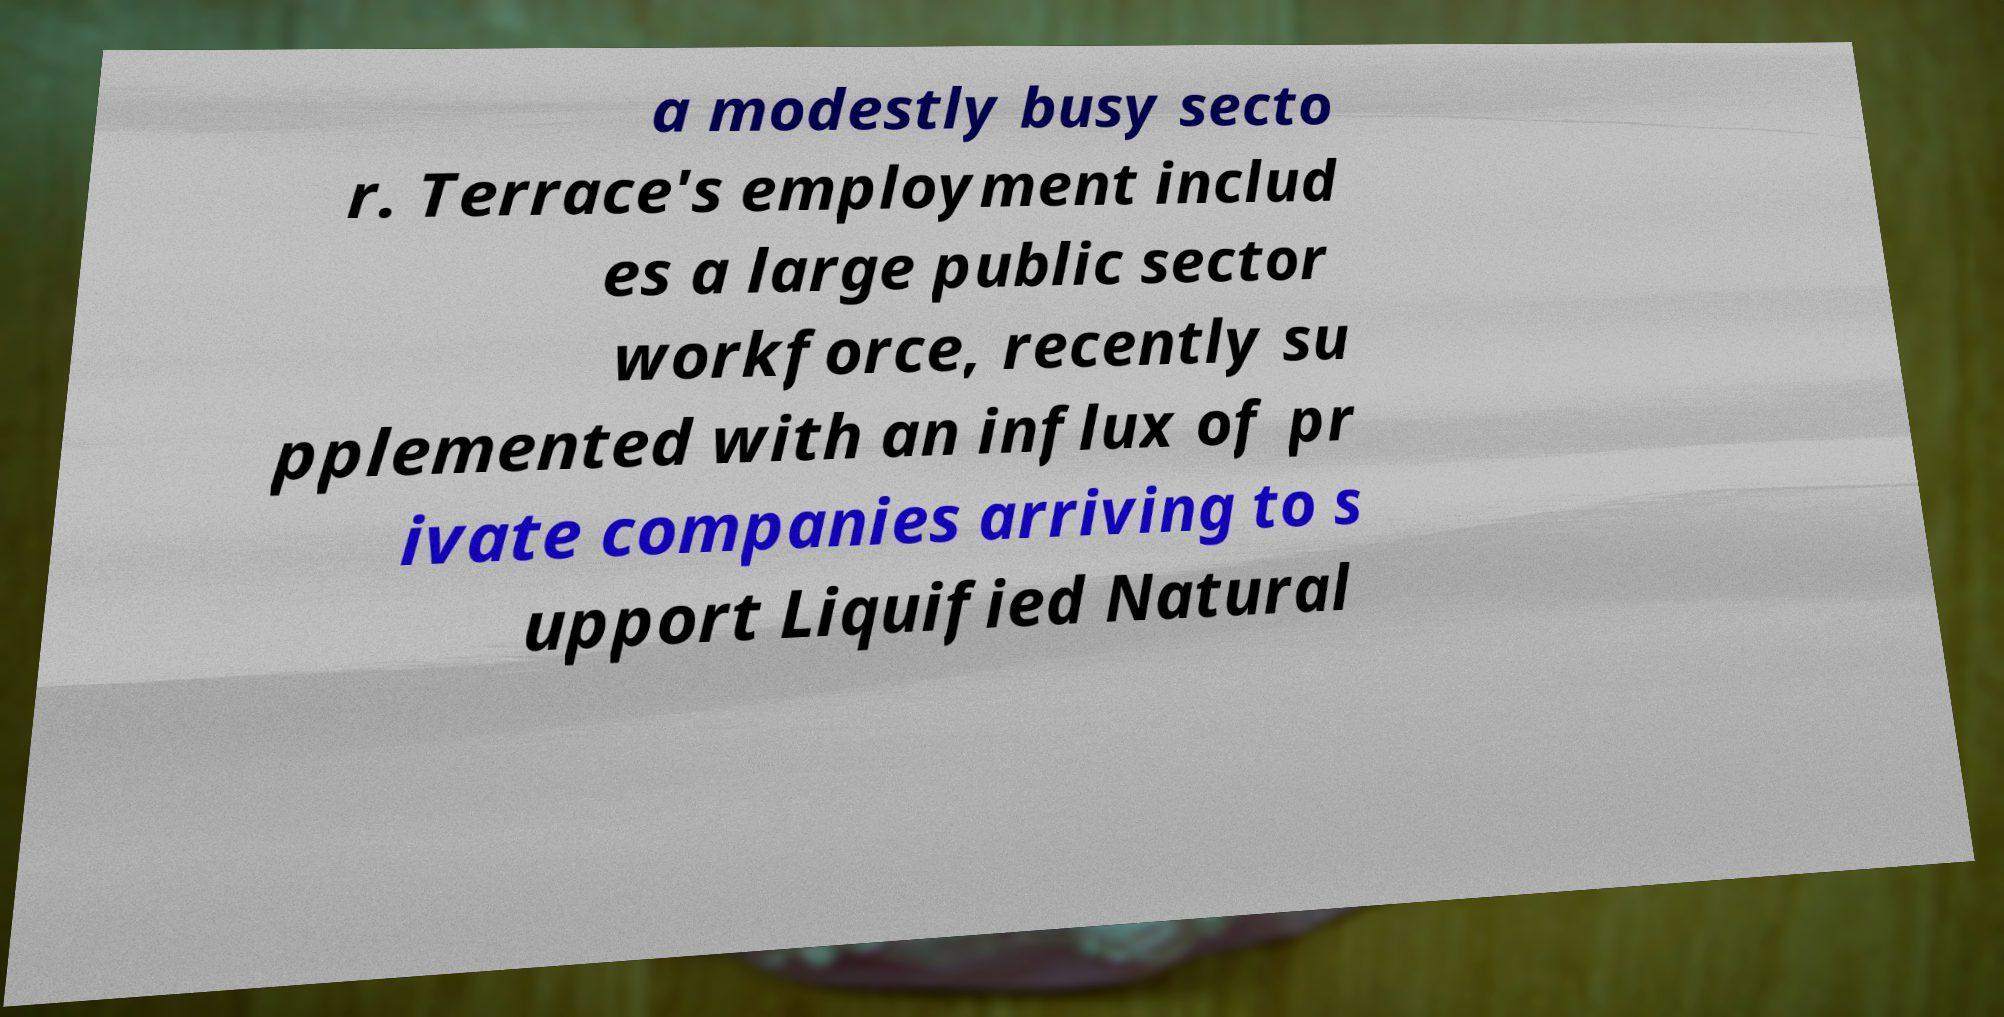What messages or text are displayed in this image? I need them in a readable, typed format. a modestly busy secto r. Terrace's employment includ es a large public sector workforce, recently su pplemented with an influx of pr ivate companies arriving to s upport Liquified Natural 